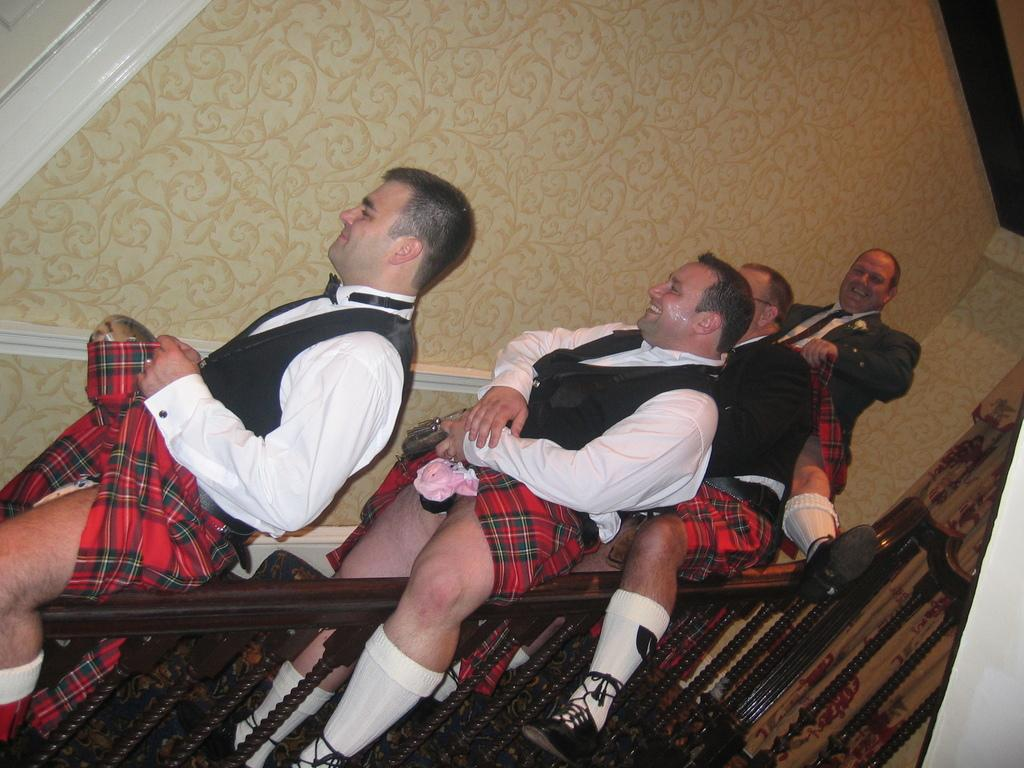What are the people in the image doing? The people in the image are sitting on the railing. What is located behind the people? There is a wall behind the people. Are there any textiles or fabric elements in the image? Yes, there are curtains in the image. What type of fowl can be seen perched on the railing in the image? There are no fowl present in the image; it features people sitting on the railing. Can you tell me how many screws are visible in the image? There is no mention of screws in the image, so it is not possible to determine their presence or quantity. 